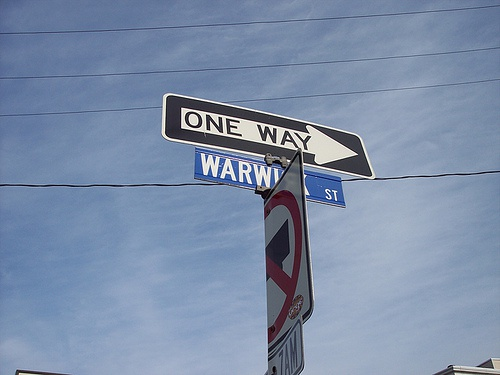Describe the objects in this image and their specific colors. I can see various objects in this image with different colors. 